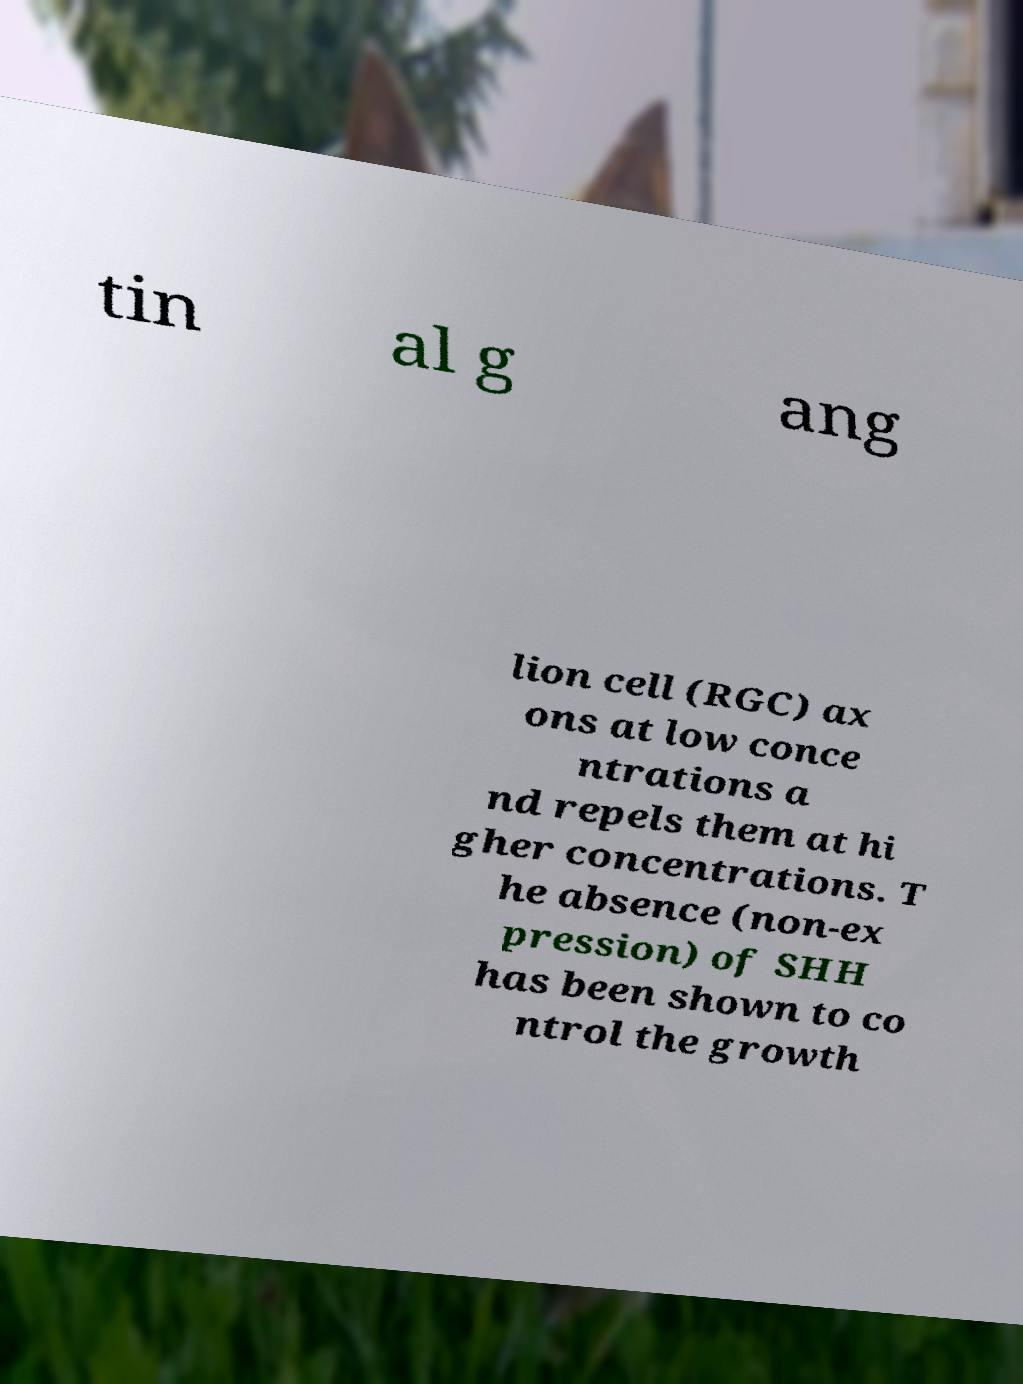There's text embedded in this image that I need extracted. Can you transcribe it verbatim? tin al g ang lion cell (RGC) ax ons at low conce ntrations a nd repels them at hi gher concentrations. T he absence (non-ex pression) of SHH has been shown to co ntrol the growth 